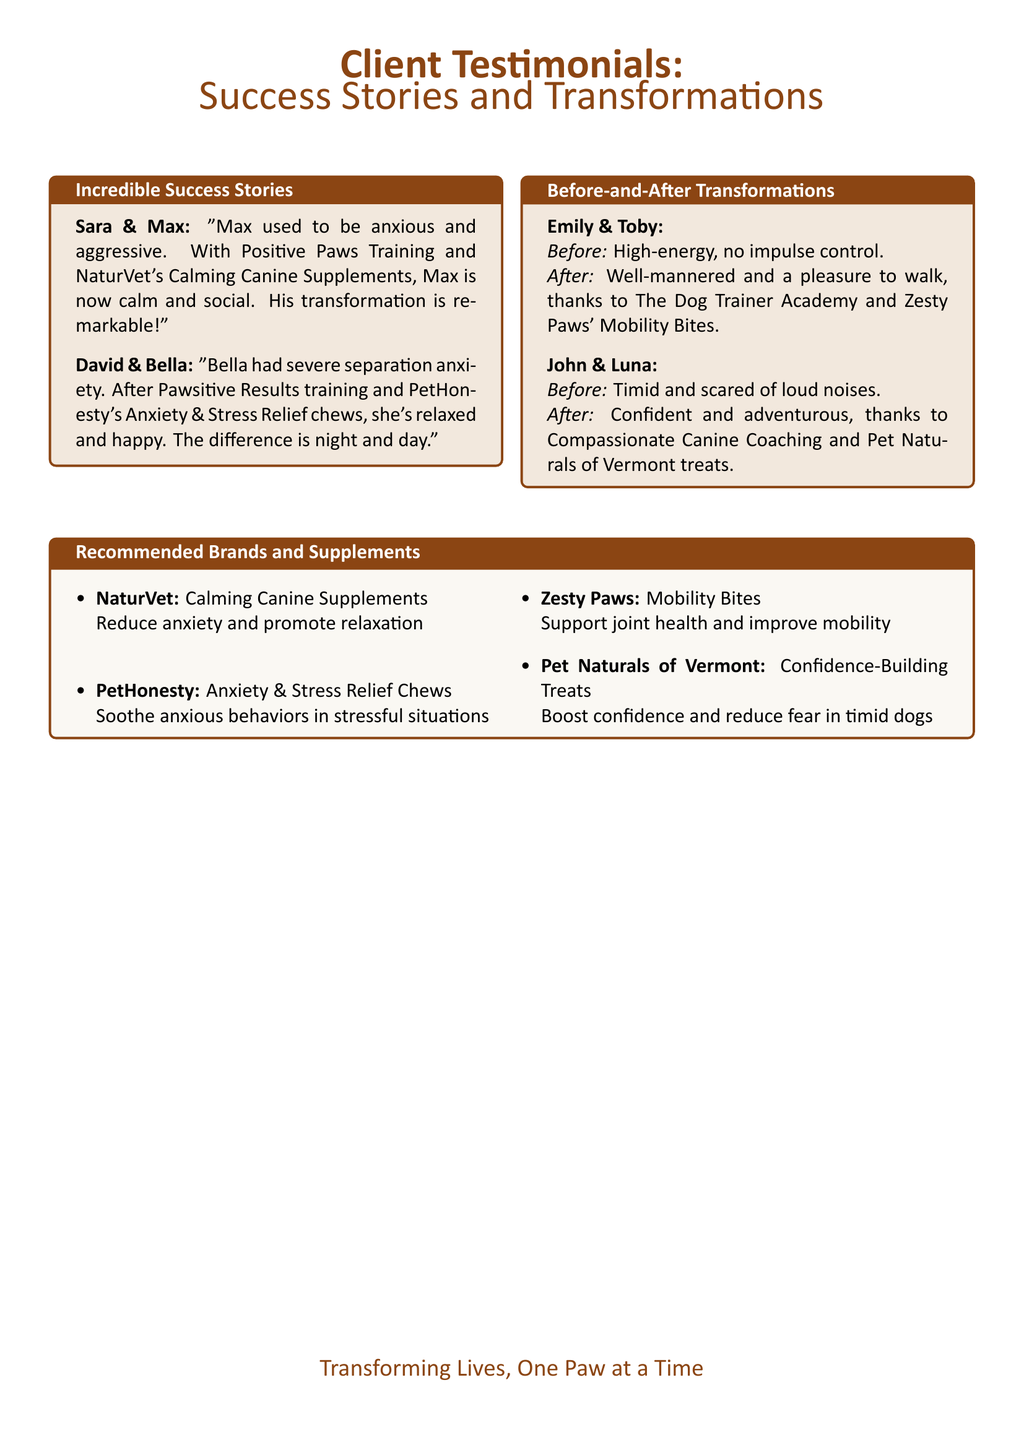What is the name of Max's owner? The document specifies that Max's owner is Sara.
Answer: Sara What supplements helped Bella with her anxiety? Bella's improvement is attributed to PetHonesty's Anxiety & Stress Relief chews.
Answer: PetHonesty's Anxiety & Stress Relief chews What was Toby's behavior before training? The document states that Toby was high-energy with no impulse control prior to training.
Answer: High-energy, no impulse control Which brand is recommended for joint health? Zesty Paws is the brand mentioned for supporting joint health.
Answer: Zesty Paws What is the outcome for Luna after training? Luna's transformation led her to become confident and adventurous.
Answer: Confident and adventurous How many success stories are showcased in the document? The document highlights four individual success stories in total.
Answer: Four Which training program helped Max's transformation? Positive Paws Training is identified as the program that helped Max.
Answer: Positive Paws Training What type of training did Emily use for Toby? The Dog Trainer Academy is the program involved in Toby's training.
Answer: The Dog Trainer Academy 